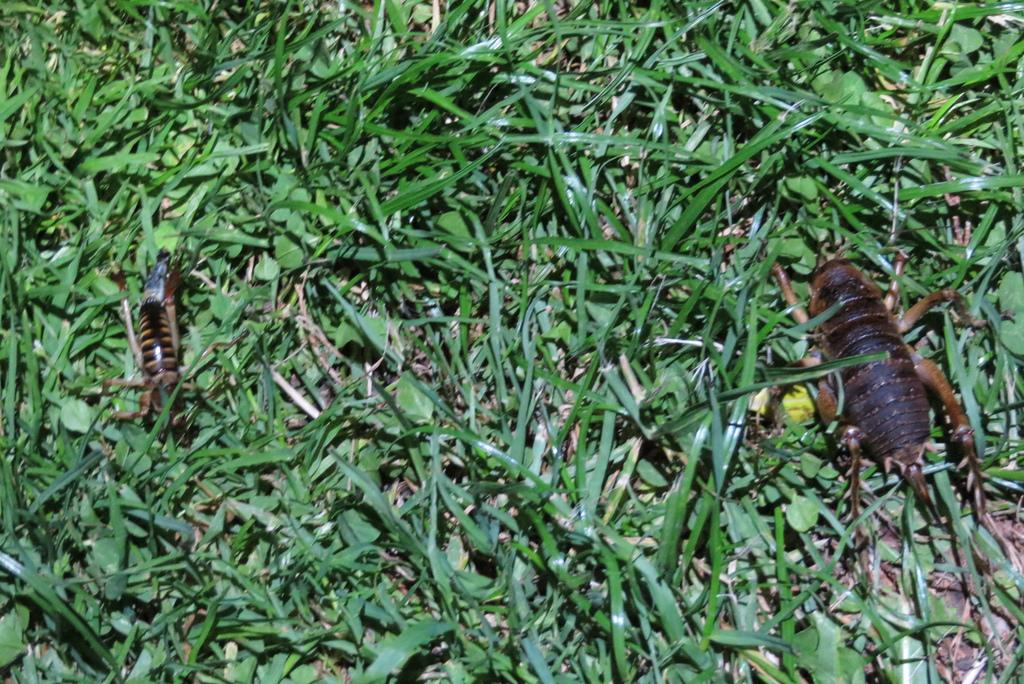How many insects are present in the image? There are two insects in the image. Where are the insects located? The insects are on the grass. What type of statement can be seen written on the fowl in the image? There is no fowl or statement present in the image; it features two insects on the grass. 